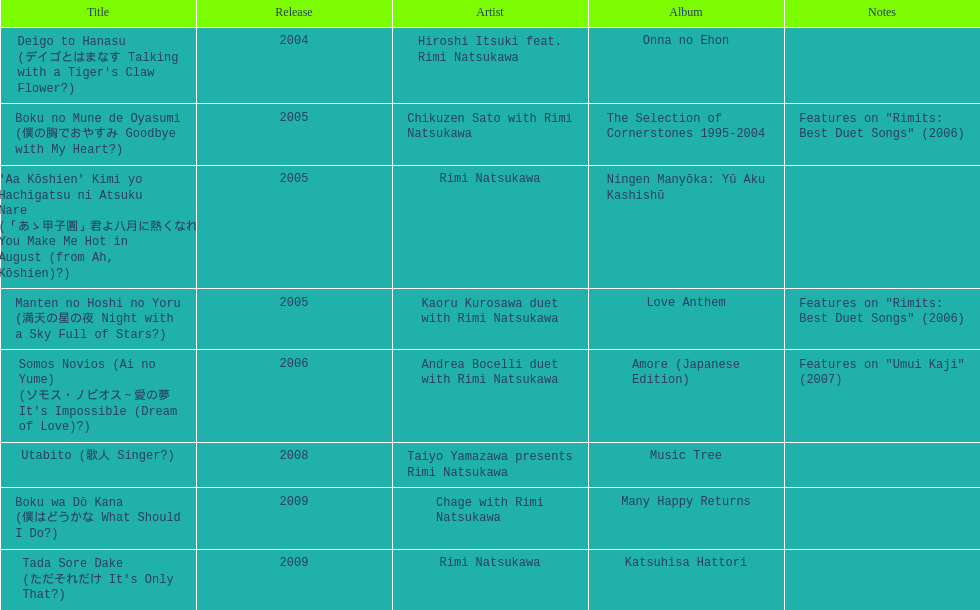What is the count of titles that feature solely one artist? 2. 